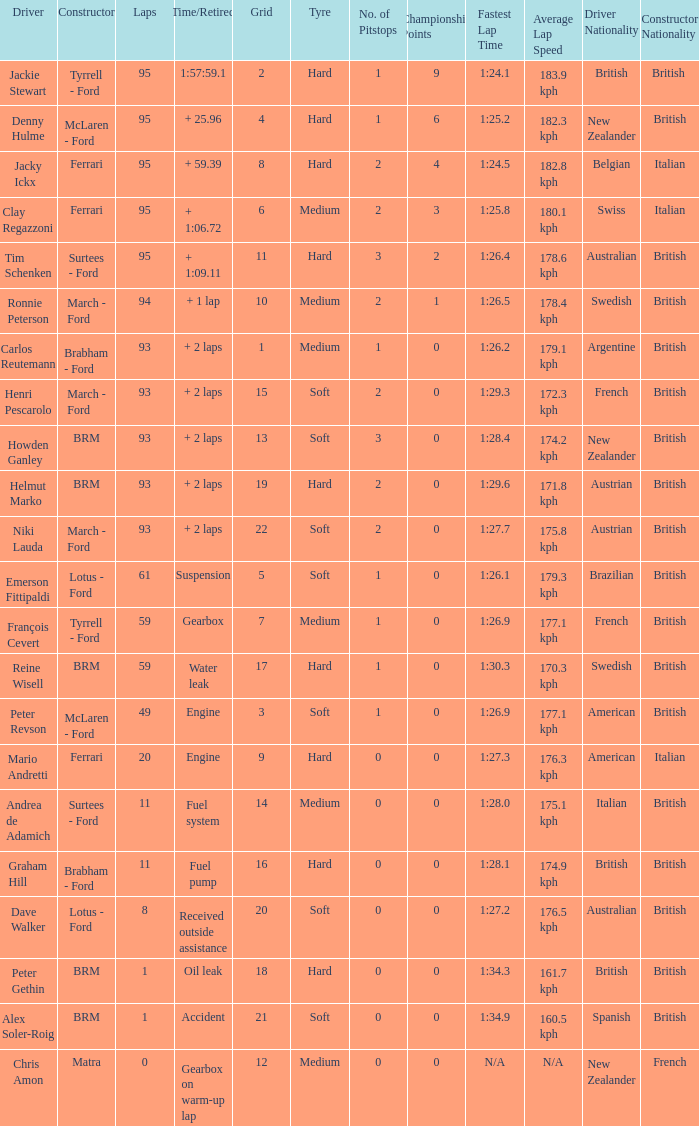What is the lowest grid with matra as constructor? 12.0. 